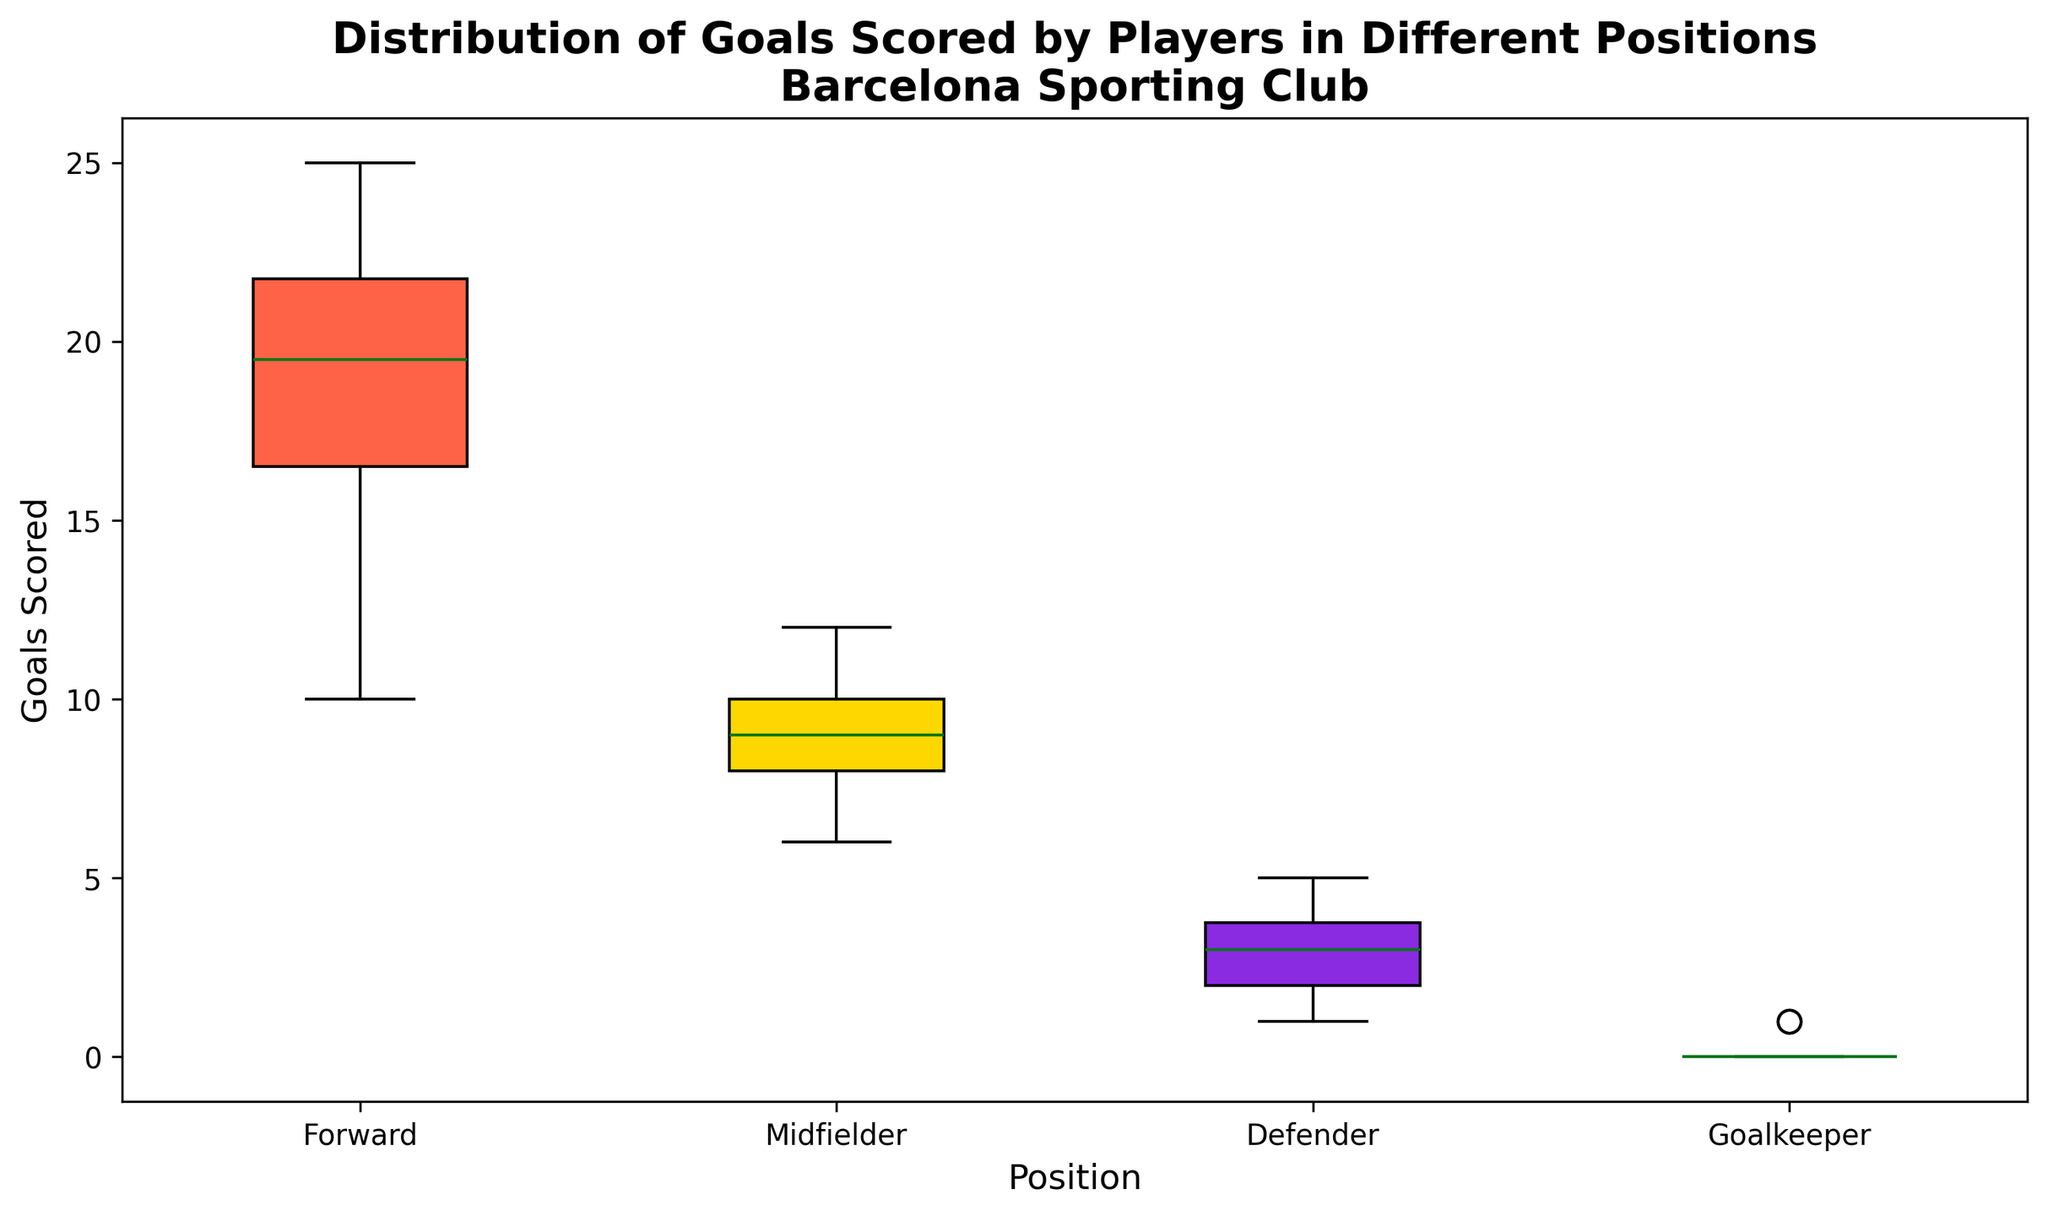What position has the highest median number of goals scored? To determine the position with the highest median, locate the middle value of each box in the plots (Forward, Midfielder, Defender, Goalkeeper). The box representing Forwards has the highest middle line.
Answer: Forward Which position has the most consistent (least spread) number of goals scored? Consistency can be evaluated by the interquartile range (IQR), which is the distance between the top and bottom of each box. The box for Goalkeepers is the smallest, indicating the least spread in the distribution of goals scored.
Answer: Goalkeeper How many positions have a median number of goals scored that is greater than 10? Check the median line in each box plot and count the positions where the line is above the 10-goal mark. Both Forwards and Midfielders have their median above 10.
Answer: 2 positions Which position has the highest maximum number of goals scored? The highest whisker (top line extending from the box) represents the highest maximum value. The Forward position has the topmost whisker.
Answer: Forward What is the interquartile range (IQR) of goals scored by Midfielders? The IQR is calculated by finding the difference between the 75th percentile (top of the box) and the 25th percentile (bottom of the box) values. For Midfielders, the upper quartile is around 11 and the lower quartile is around 8.
Answer: 3 goals Which position showed the lowest minimum number of goals scored? The lowest whisker (bottom line extending from the box) indicates the minimum value. Goalkeepers have the lowest whisker with a value of 0.
Answer: Goalkeeper Between Forwards and Midfielders, which group has a larger interquartile range (IQR)? Compare the height of the boxes for Forwards and Midfielders. Forwards have a taller box suggesting a larger IQR.
Answer: Forwards Are there any outliers in the data for Defenders? Outliers are usually indicated by individual points outside the whiskers of the box plot. For Defenders, there are one or two points lying beyond the whiskers, signifying the presence of outliers.
Answer: Yes What is the median number of goals scored by Defenders? The median is represented by the line inside the box plot for Defenders. This line is at 3.
Answer: 3 goals Which position has the highest third quartile value of goals scored? The third quartile is represented by the upper edge of the box. The Forward position has the highest upper edge of the box, indicating the highest third quartile value.
Answer: Forward 